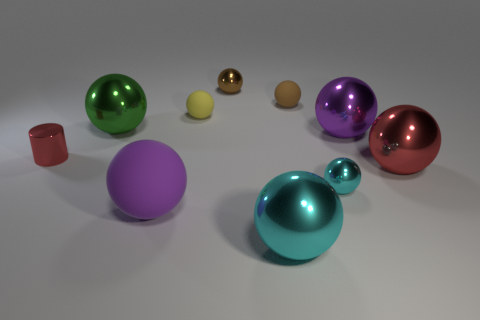Can you suggest what the different sizes of spheres might represent in an artistic interpretation? Artistically, the different sizes of the spheres could represent the diversity and hierarchy of elements within a system or community. The larger spheres might symbolize more prominent or influential components, while the smaller ones could indicate lesser but still integral parts. The variety in size allows for a visual representation of balance and the concept that each part, regardless of size, plays a role in the larger whole. 